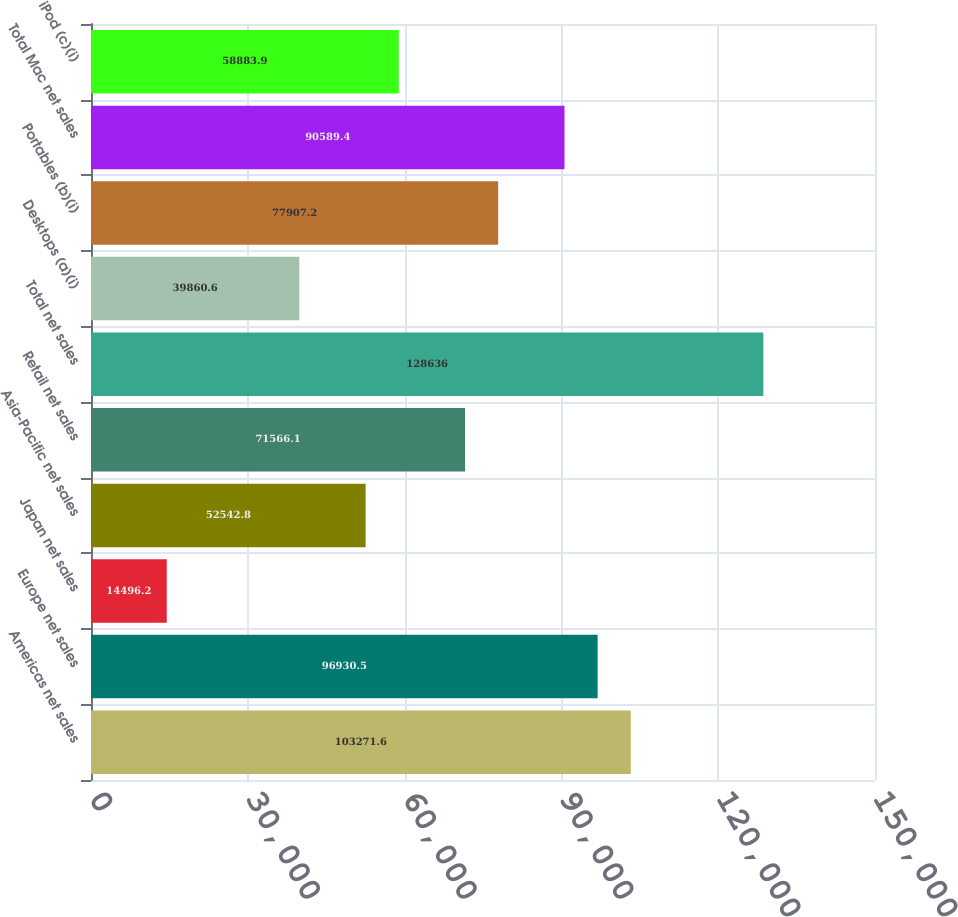Convert chart. <chart><loc_0><loc_0><loc_500><loc_500><bar_chart><fcel>Americas net sales<fcel>Europe net sales<fcel>Japan net sales<fcel>Asia-Pacific net sales<fcel>Retail net sales<fcel>Total net sales<fcel>Desktops (a)(i)<fcel>Portables (b)(i)<fcel>Total Mac net sales<fcel>iPod (c)(i)<nl><fcel>103272<fcel>96930.5<fcel>14496.2<fcel>52542.8<fcel>71566.1<fcel>128636<fcel>39860.6<fcel>77907.2<fcel>90589.4<fcel>58883.9<nl></chart> 